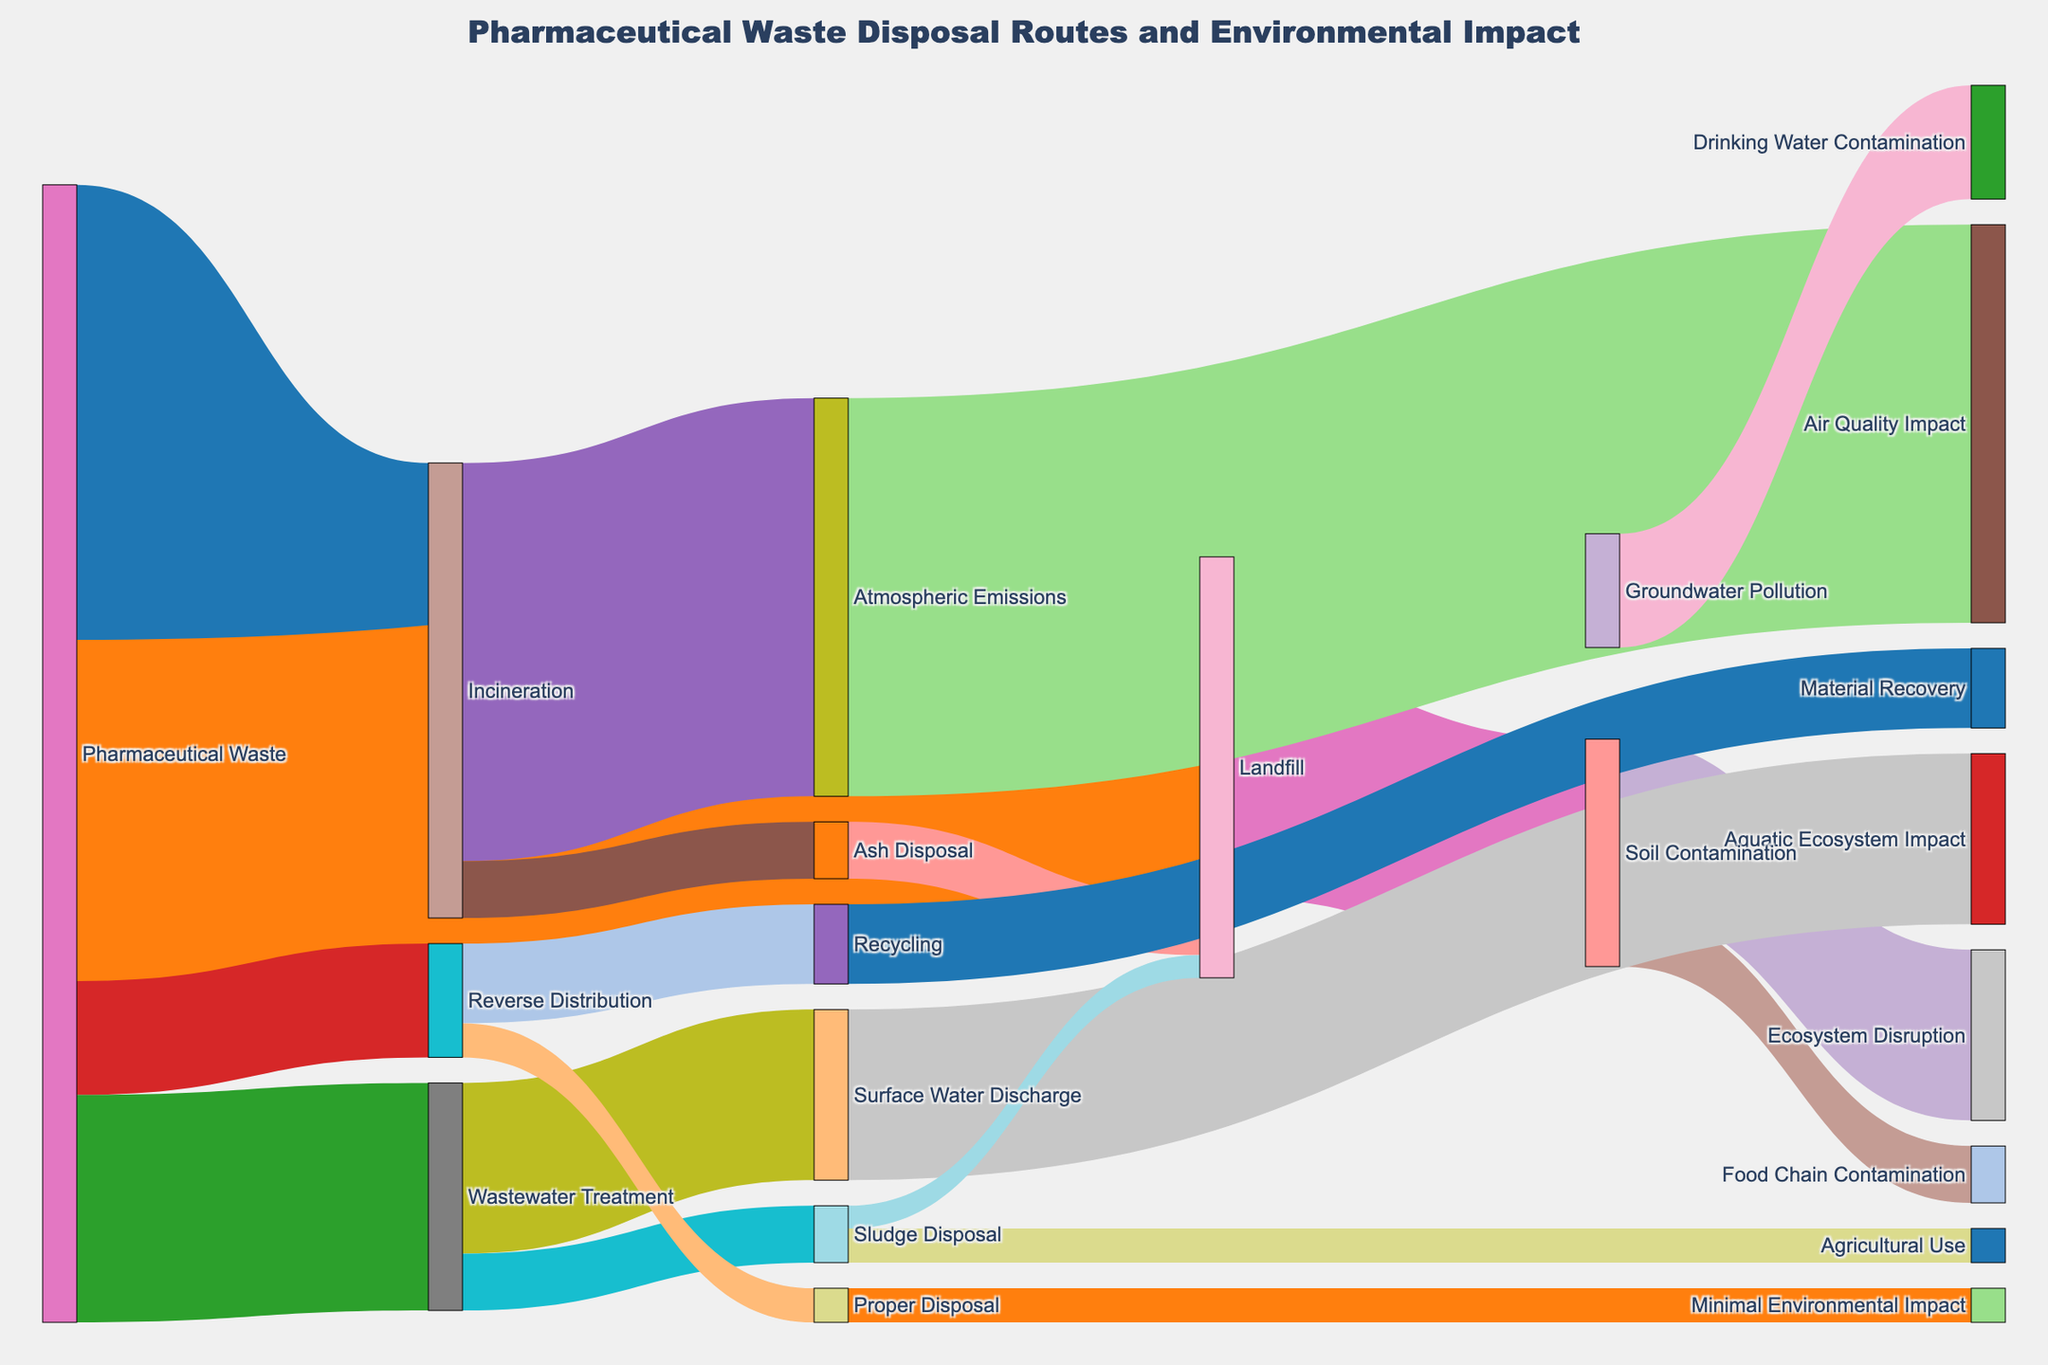Which waste disposal method contributes the most to atmospheric emissions? From the Sankey Diagram, "Incineration" contributes 35 units to "Atmospheric Emissions", which is the highest among other paths visualized.
Answer: Incineration What is the total quantity of pharmaceutical waste processed through all disposal routes? From the Sankey Diagram, the values for all routes sum up to 40 (Incineration) + 30 (Landfill) + 20 (Wastewater Treatment) + 10 (Reverse Distribution) = 100.
Answer: 100 How much of the pharmaceutical waste processed through wastewater treatment ends up affecting aquatic ecosystems? From the Sankey Diagram, "Wastewater Treatment" sends 15 units to "Surface Water Discharge", which eventually affects the "Aquatic Ecosystem".
Answer: 15 Which disposal method results in the least amount of environmental impact in the final stage? From the Sankey Diagram, "Proper Disposal" results in "Minimal Environmental Impact" with 3 units. This is the least amount compared to other final-stage impacts.
Answer: Proper Disposal What is the total amount of waste that ends up in landfills, whether directly or indirectly? "Pharmaceutical Waste" sends 30 units to "Landfill" directly. Additionally, "Ash Disposal" from "Incineration" sends 5 units, and "Sludge Disposal" from "Wastewater Treatment" sends 2 units to "Landfill". Total = 30 + 5 + 2 = 37.
Answer: 37 Between soil contamination and groundwater pollution through landfills, which has a higher environmental impact? "Landfill" sends 20 units to "Soil Contamination" and 10 units to "Groundwater Pollution". Soil contamination has the higher impact.
Answer: Soil Contamination How much pharmaceutical waste is properly disposed of via the reverse distribution route? From the Sankey Diagram, "Reverse Distribution" directs 3 units to "Proper Disposal".
Answer: 3 What proportion of incinerated waste turns into ash disposal? From the Sankey Diagram, "Incineration" accounts for 40 units, out of which 5 units end up as "Ash Disposal". The proportion is calculated as 5 / 40 = 1/8 or 0.125.
Answer: 0.125 How does the amount of pharmaceutical waste that undergoes wastewater treatment compare to the amount that gets incinerated? "Pharmaceutical Waste" sends 20 units to "Wastewater Treatment" and 40 units to "Incineration". Thus, half as much waste goes through wastewater treatment as compared to incineration.
Answer: Half as much Which disposal method has a direct influence on the food chain, and what is its magnitude? From the Sankey Diagram, "Soil Contamination" from "Landfill" impacts "Food Chain Contamination" with a magnitude of 5 units.
Answer: Landfill, 5 